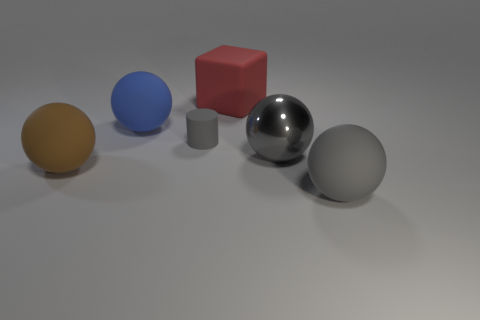Add 3 matte cylinders. How many objects exist? 9 Subtract all cylinders. How many objects are left? 5 Subtract all tiny rubber cylinders. Subtract all cylinders. How many objects are left? 4 Add 4 large gray metallic balls. How many large gray metallic balls are left? 5 Add 5 cylinders. How many cylinders exist? 6 Subtract 0 yellow cylinders. How many objects are left? 6 